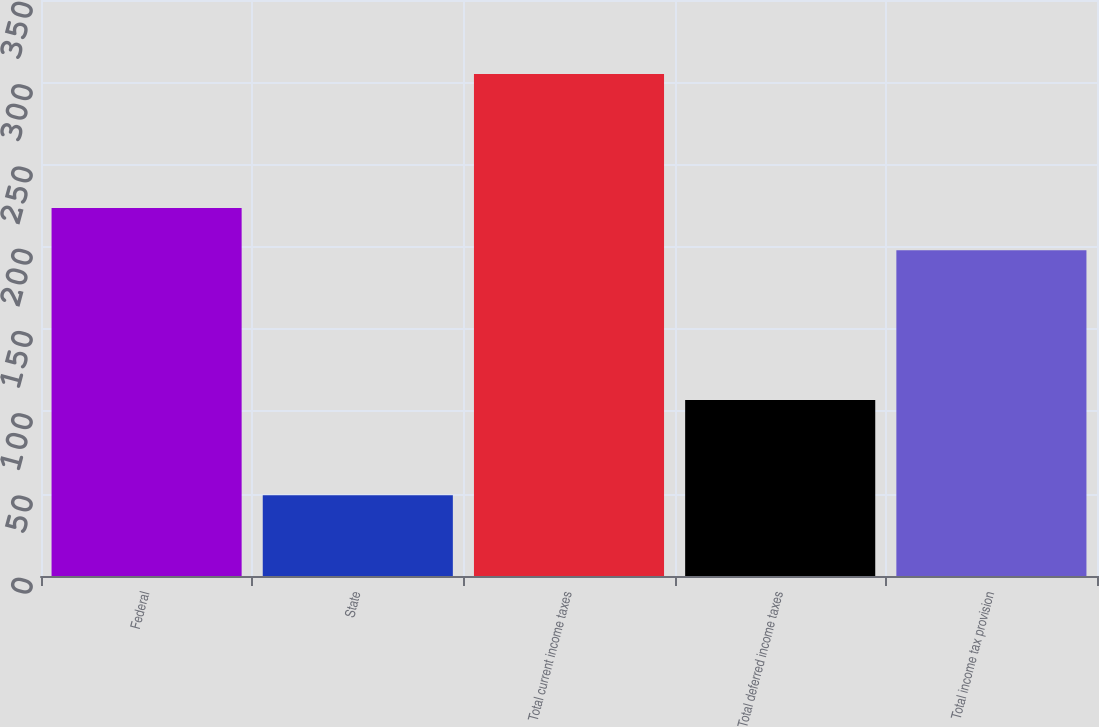<chart> <loc_0><loc_0><loc_500><loc_500><bar_chart><fcel>Federal<fcel>State<fcel>Total current income taxes<fcel>Total deferred income taxes<fcel>Total income tax provision<nl><fcel>223.6<fcel>49<fcel>305<fcel>107<fcel>198<nl></chart> 